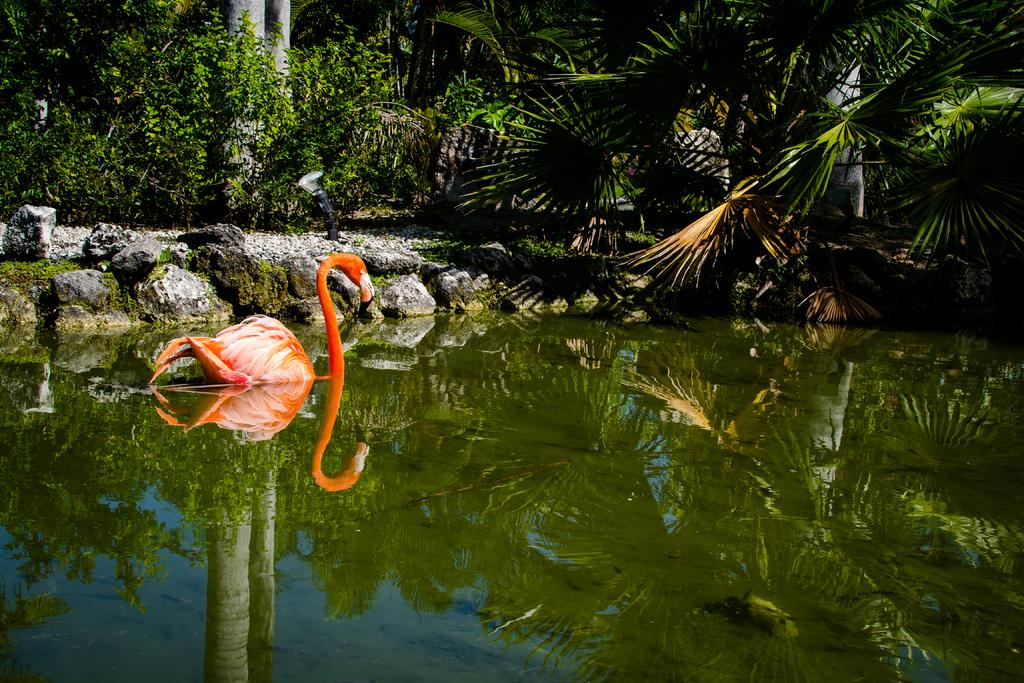What is the main subject of the image? There is a bird on the surface of water in the image. What can be seen in the background of the image? There is greenery and rocky land in the background of the image. What type of bat can be seen flying over the bird in the image? There is no bat present in the image; it only features a bird on the water and the background landscape. 